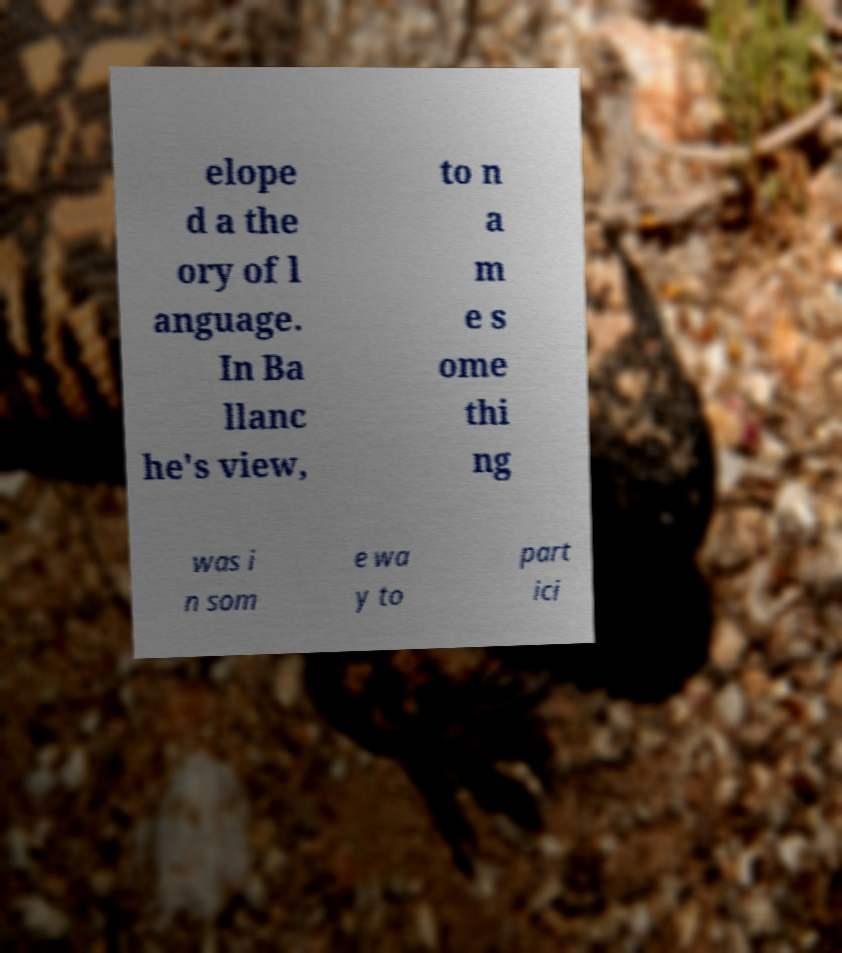I need the written content from this picture converted into text. Can you do that? elope d a the ory of l anguage. In Ba llanc he's view, to n a m e s ome thi ng was i n som e wa y to part ici 